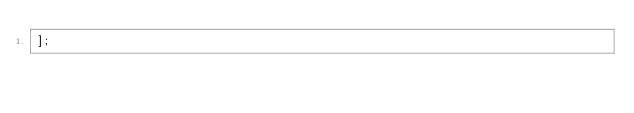<code> <loc_0><loc_0><loc_500><loc_500><_JavaScript_>];
</code> 